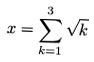<formula> <loc_0><loc_0><loc_500><loc_500>x = \sum _ { k = 1 } ^ { 3 } \sqrt { k }</formula> 